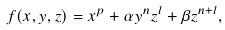Convert formula to latex. <formula><loc_0><loc_0><loc_500><loc_500>f ( x , y , z ) = x ^ { p } + \alpha y ^ { n } z ^ { l } + \beta z ^ { n + l } ,</formula> 